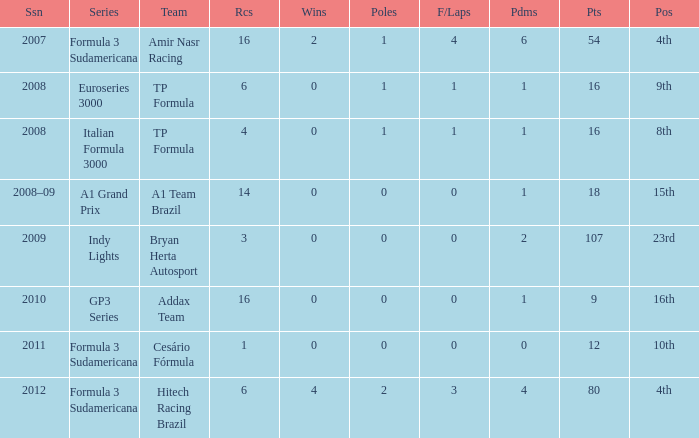Could you parse the entire table? {'header': ['Ssn', 'Series', 'Team', 'Rcs', 'Wins', 'Poles', 'F/Laps', 'Pdms', 'Pts', 'Pos'], 'rows': [['2007', 'Formula 3 Sudamericana', 'Amir Nasr Racing', '16', '2', '1', '4', '6', '54', '4th'], ['2008', 'Euroseries 3000', 'TP Formula', '6', '0', '1', '1', '1', '16', '9th'], ['2008', 'Italian Formula 3000', 'TP Formula', '4', '0', '1', '1', '1', '16', '8th'], ['2008–09', 'A1 Grand Prix', 'A1 Team Brazil', '14', '0', '0', '0', '1', '18', '15th'], ['2009', 'Indy Lights', 'Bryan Herta Autosport', '3', '0', '0', '0', '2', '107', '23rd'], ['2010', 'GP3 Series', 'Addax Team', '16', '0', '0', '0', '1', '9', '16th'], ['2011', 'Formula 3 Sudamericana', 'Cesário Fórmula', '1', '0', '0', '0', '0', '12', '10th'], ['2012', 'Formula 3 Sudamericana', 'Hitech Racing Brazil', '6', '4', '2', '3', '4', '80', '4th']]} What team did he compete for in the GP3 series? Addax Team. 